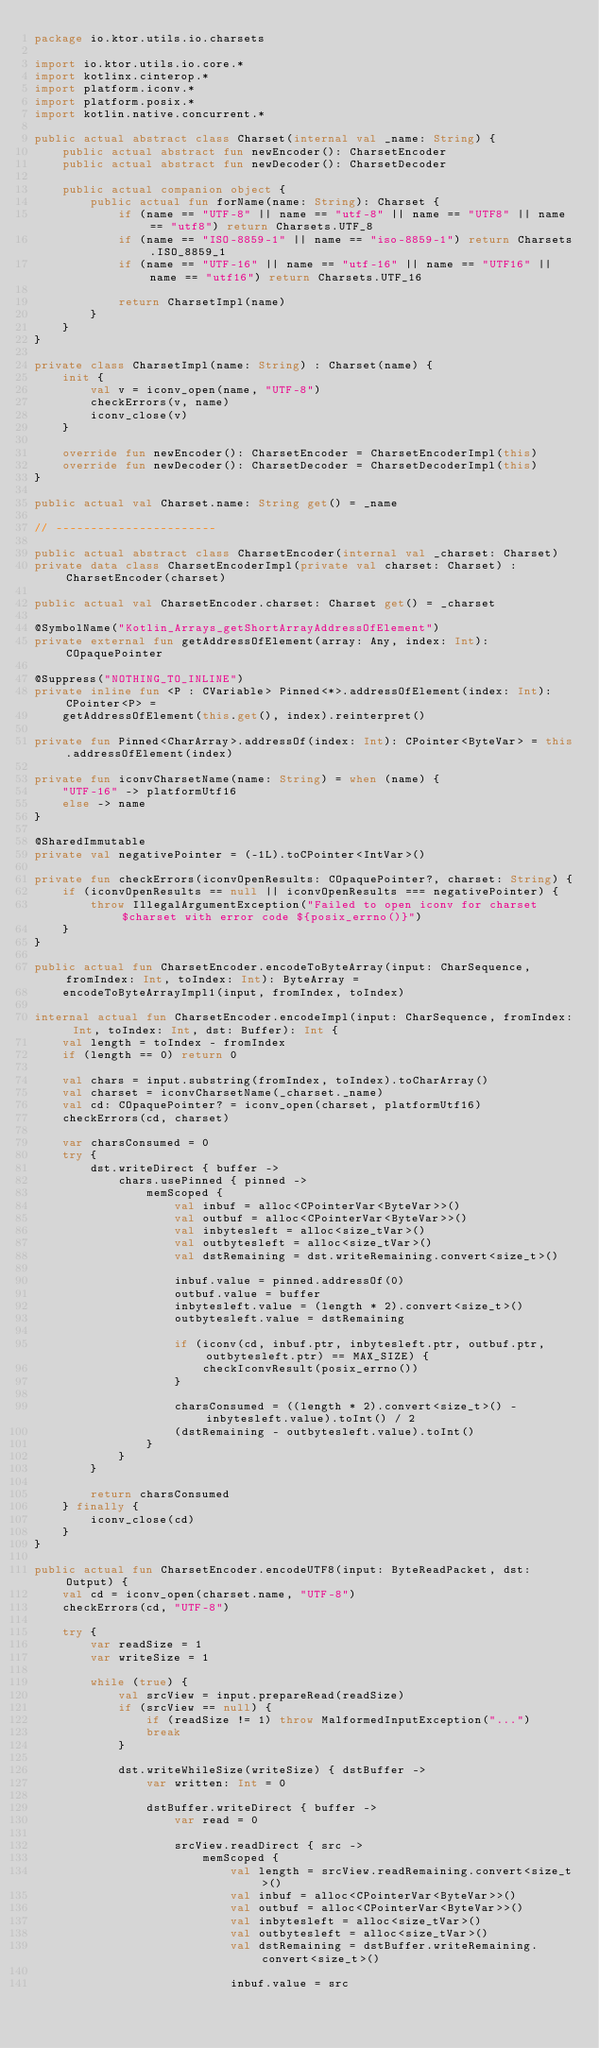Convert code to text. <code><loc_0><loc_0><loc_500><loc_500><_Kotlin_>package io.ktor.utils.io.charsets

import io.ktor.utils.io.core.*
import kotlinx.cinterop.*
import platform.iconv.*
import platform.posix.*
import kotlin.native.concurrent.*

public actual abstract class Charset(internal val _name: String) {
    public actual abstract fun newEncoder(): CharsetEncoder
    public actual abstract fun newDecoder(): CharsetDecoder

    public actual companion object {
        public actual fun forName(name: String): Charset {
            if (name == "UTF-8" || name == "utf-8" || name == "UTF8" || name == "utf8") return Charsets.UTF_8
            if (name == "ISO-8859-1" || name == "iso-8859-1") return Charsets.ISO_8859_1
            if (name == "UTF-16" || name == "utf-16" || name == "UTF16" || name == "utf16") return Charsets.UTF_16

            return CharsetImpl(name)
        }
    }
}

private class CharsetImpl(name: String) : Charset(name) {
    init {
        val v = iconv_open(name, "UTF-8")
        checkErrors(v, name)
        iconv_close(v)
    }

    override fun newEncoder(): CharsetEncoder = CharsetEncoderImpl(this)
    override fun newDecoder(): CharsetDecoder = CharsetDecoderImpl(this)
}

public actual val Charset.name: String get() = _name

// -----------------------

public actual abstract class CharsetEncoder(internal val _charset: Charset)
private data class CharsetEncoderImpl(private val charset: Charset) : CharsetEncoder(charset)

public actual val CharsetEncoder.charset: Charset get() = _charset

@SymbolName("Kotlin_Arrays_getShortArrayAddressOfElement")
private external fun getAddressOfElement(array: Any, index: Int): COpaquePointer

@Suppress("NOTHING_TO_INLINE")
private inline fun <P : CVariable> Pinned<*>.addressOfElement(index: Int): CPointer<P> =
    getAddressOfElement(this.get(), index).reinterpret()

private fun Pinned<CharArray>.addressOf(index: Int): CPointer<ByteVar> = this.addressOfElement(index)

private fun iconvCharsetName(name: String) = when (name) {
    "UTF-16" -> platformUtf16
    else -> name
}

@SharedImmutable
private val negativePointer = (-1L).toCPointer<IntVar>()

private fun checkErrors(iconvOpenResults: COpaquePointer?, charset: String) {
    if (iconvOpenResults == null || iconvOpenResults === negativePointer) {
        throw IllegalArgumentException("Failed to open iconv for charset $charset with error code ${posix_errno()}")
    }
}

public actual fun CharsetEncoder.encodeToByteArray(input: CharSequence, fromIndex: Int, toIndex: Int): ByteArray =
    encodeToByteArrayImpl1(input, fromIndex, toIndex)

internal actual fun CharsetEncoder.encodeImpl(input: CharSequence, fromIndex: Int, toIndex: Int, dst: Buffer): Int {
    val length = toIndex - fromIndex
    if (length == 0) return 0

    val chars = input.substring(fromIndex, toIndex).toCharArray()
    val charset = iconvCharsetName(_charset._name)
    val cd: COpaquePointer? = iconv_open(charset, platformUtf16)
    checkErrors(cd, charset)

    var charsConsumed = 0
    try {
        dst.writeDirect { buffer ->
            chars.usePinned { pinned ->
                memScoped {
                    val inbuf = alloc<CPointerVar<ByteVar>>()
                    val outbuf = alloc<CPointerVar<ByteVar>>()
                    val inbytesleft = alloc<size_tVar>()
                    val outbytesleft = alloc<size_tVar>()
                    val dstRemaining = dst.writeRemaining.convert<size_t>()

                    inbuf.value = pinned.addressOf(0)
                    outbuf.value = buffer
                    inbytesleft.value = (length * 2).convert<size_t>()
                    outbytesleft.value = dstRemaining

                    if (iconv(cd, inbuf.ptr, inbytesleft.ptr, outbuf.ptr, outbytesleft.ptr) == MAX_SIZE) {
                        checkIconvResult(posix_errno())
                    }

                    charsConsumed = ((length * 2).convert<size_t>() - inbytesleft.value).toInt() / 2
                    (dstRemaining - outbytesleft.value).toInt()
                }
            }
        }

        return charsConsumed
    } finally {
        iconv_close(cd)
    }
}

public actual fun CharsetEncoder.encodeUTF8(input: ByteReadPacket, dst: Output) {
    val cd = iconv_open(charset.name, "UTF-8")
    checkErrors(cd, "UTF-8")

    try {
        var readSize = 1
        var writeSize = 1

        while (true) {
            val srcView = input.prepareRead(readSize)
            if (srcView == null) {
                if (readSize != 1) throw MalformedInputException("...")
                break
            }

            dst.writeWhileSize(writeSize) { dstBuffer ->
                var written: Int = 0

                dstBuffer.writeDirect { buffer ->
                    var read = 0

                    srcView.readDirect { src ->
                        memScoped {
                            val length = srcView.readRemaining.convert<size_t>()
                            val inbuf = alloc<CPointerVar<ByteVar>>()
                            val outbuf = alloc<CPointerVar<ByteVar>>()
                            val inbytesleft = alloc<size_tVar>()
                            val outbytesleft = alloc<size_tVar>()
                            val dstRemaining = dstBuffer.writeRemaining.convert<size_t>()

                            inbuf.value = src</code> 